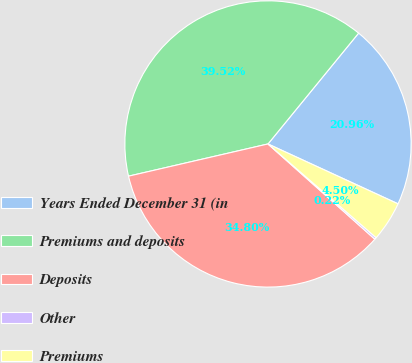Convert chart. <chart><loc_0><loc_0><loc_500><loc_500><pie_chart><fcel>Years Ended December 31 (in<fcel>Premiums and deposits<fcel>Deposits<fcel>Other<fcel>Premiums<nl><fcel>20.96%<fcel>39.52%<fcel>34.8%<fcel>0.22%<fcel>4.5%<nl></chart> 